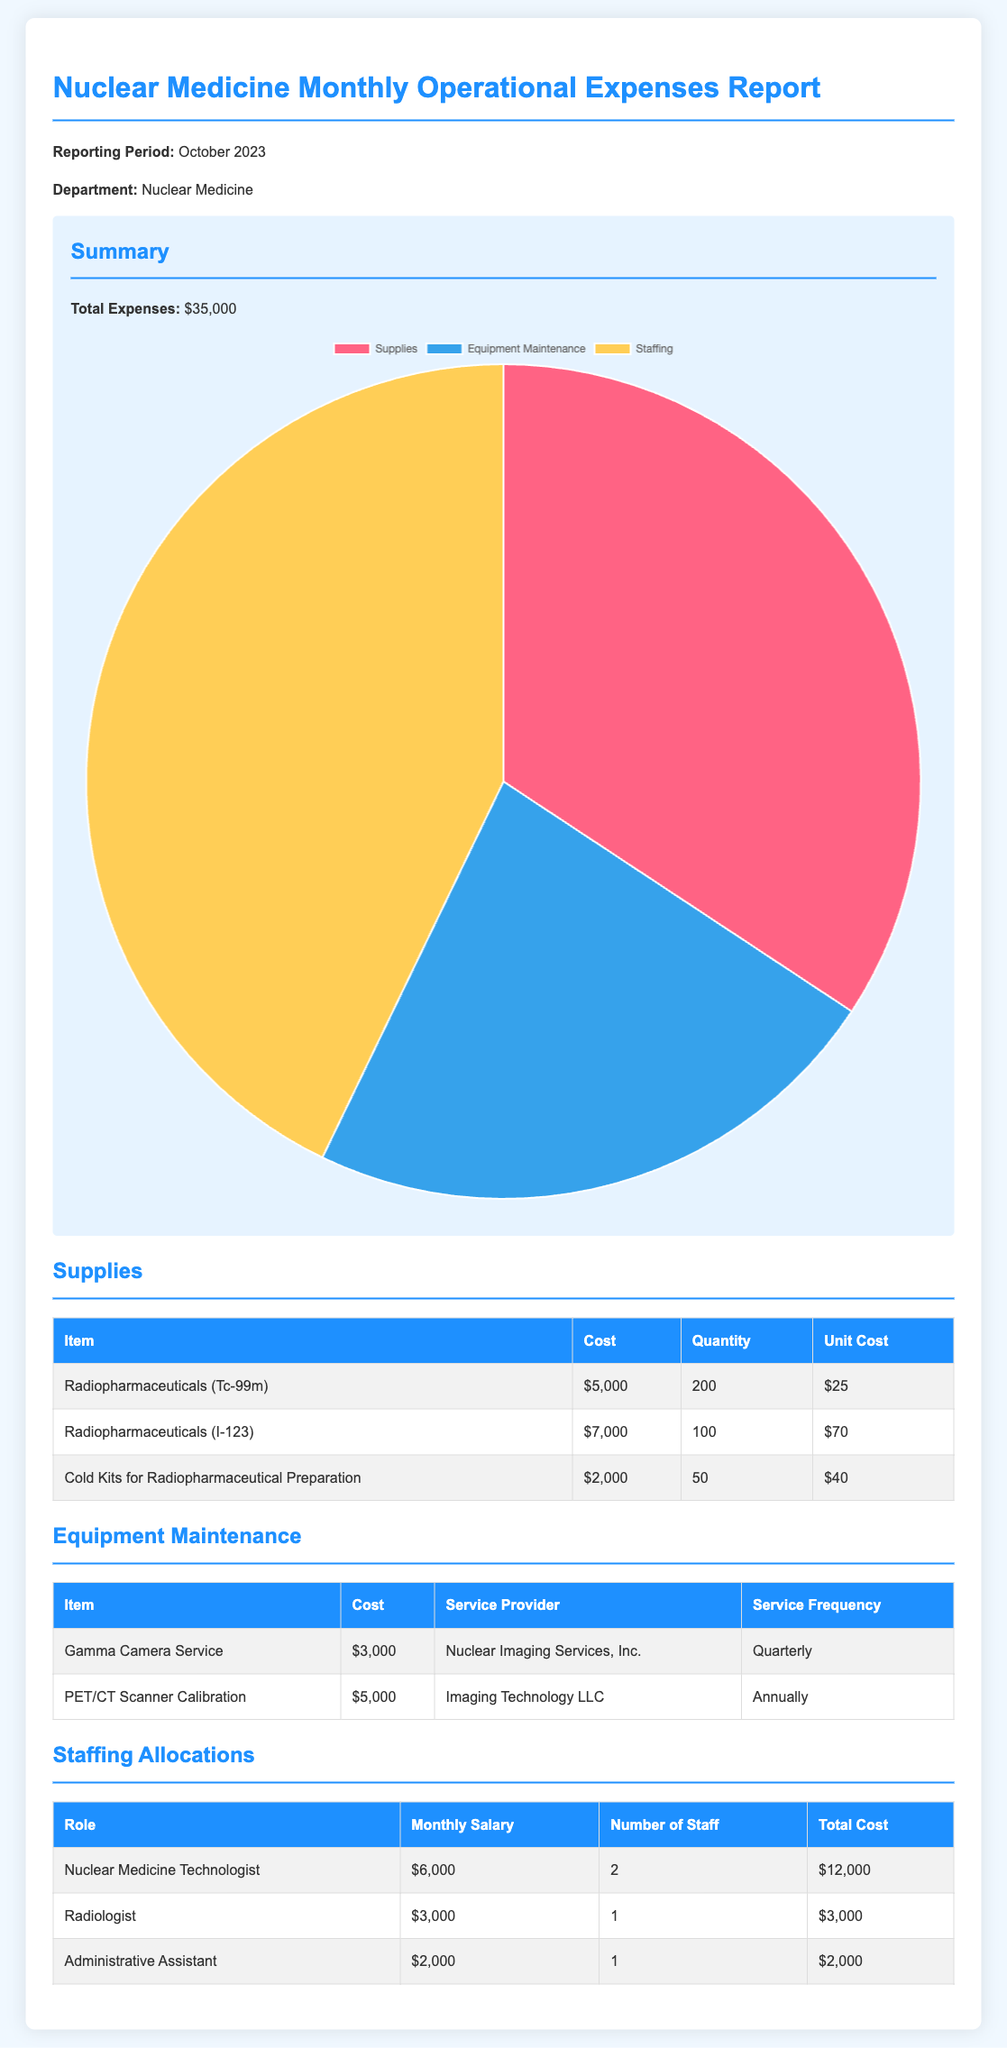What are the total expenses? The total expenses are summarized at the beginning of the document, which indicates the overall expense amount.
Answer: $35,000 What is the cost of Radiopharmaceuticals (I-123)? In the supplies section, the cost of Radiopharmaceuticals (I-123) is specified alongside its quantity and unit cost.
Answer: $7,000 How many Nuclear Medicine Technologists are employed? The staffing allocations table provides the number of staff for each role which includes the Nuclear Medicine Technologists.
Answer: 2 What is the monthly salary of the Radiologist? The staffing allocations section lists the roles, including the corresponding salaries, focusing on the Radiologist's pay.
Answer: $3,000 Who is the service provider for Gamma Camera Service? The equipment maintenance table includes details such as service provider names for specific maintenance services.
Answer: Nuclear Imaging Services, Inc What percentage of total expenses is attributed to supplies? The pie chart data indicates the distribution of expenses among different categories, allowing calculation of the percentage represented by supplies.
Answer: 34.29% What is the total cost for staffing allocations? The total cost for staffing is calculated based on the monthly salary and number of staff for each role listed in the staffing section.
Answer: $17,000 How often is the PET/CT Scanner calibration performed? The equipment maintenance table includes service frequency details for each maintenance item, including the PET/CT Scanner.
Answer: Annually What is the unit cost for Cold Kits for Radiopharmaceutical Preparation? The unit cost is provided in the supplies table, detailing the cost per unit for each item listed.
Answer: $40 